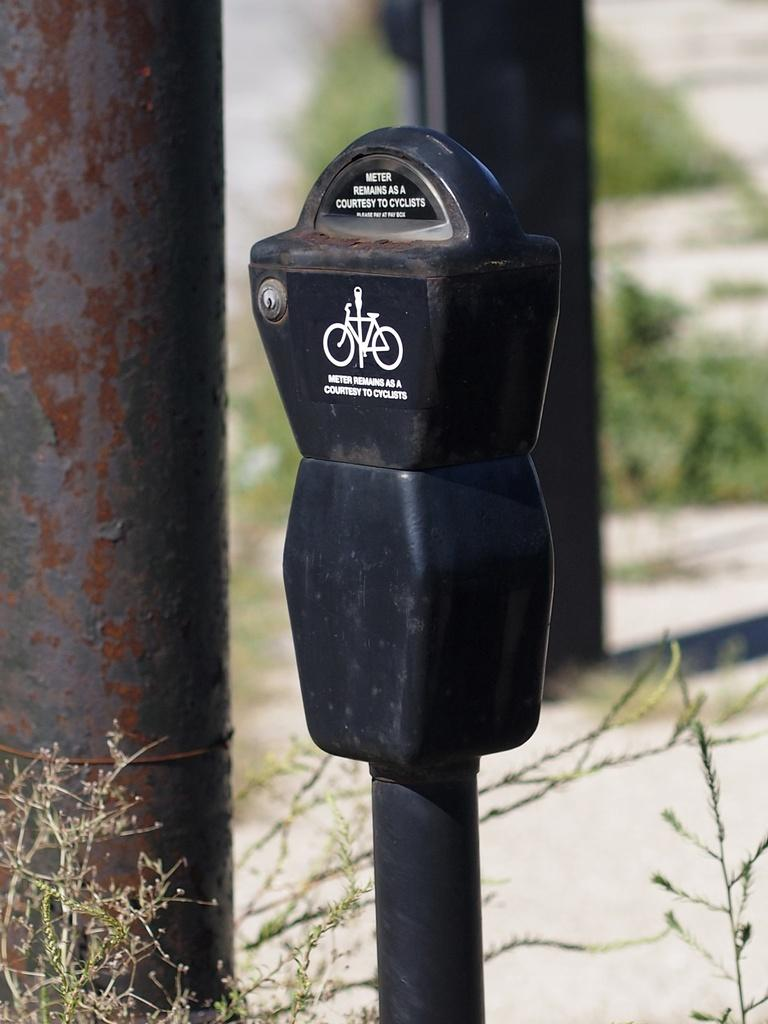Provide a one-sentence caption for the provided image. A parking meter in a grassy area that says Meter remains as a courtesy to cyclists. 